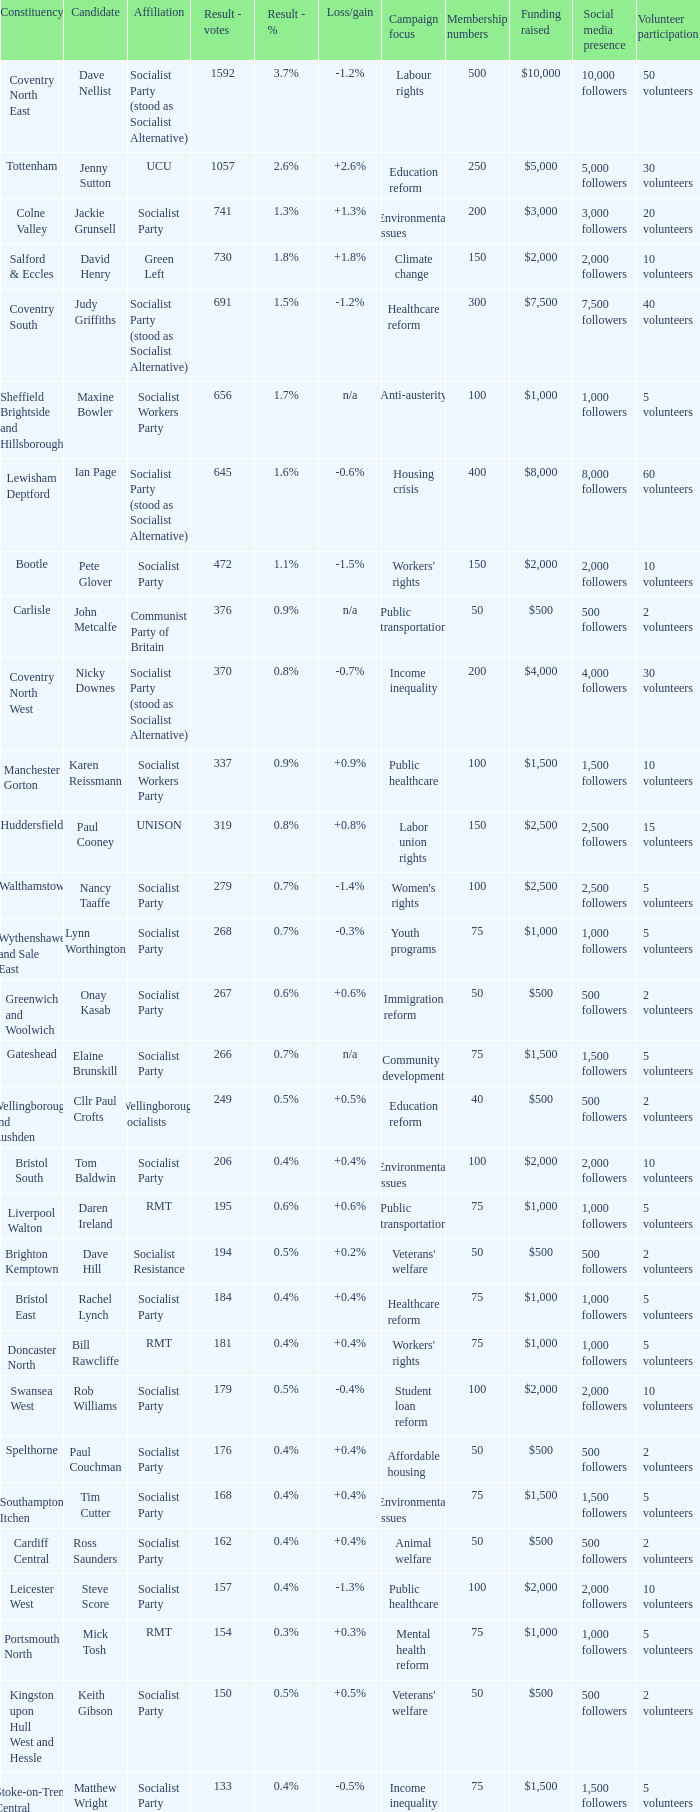What are all the associations connected with candidate daren ireland? RMT. 